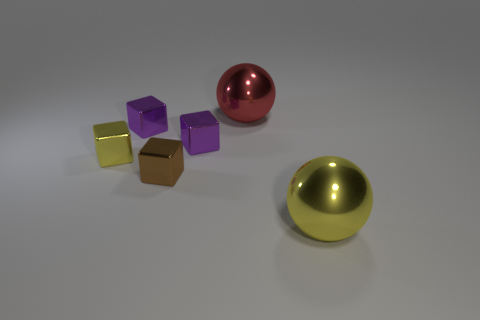Subtract all purple blocks. How many were subtracted if there are1purple blocks left? 1 Add 3 yellow shiny things. How many objects exist? 9 Subtract all yellow metal cubes. How many cubes are left? 3 Subtract 1 cubes. How many cubes are left? 3 Subtract all green cubes. Subtract all purple spheres. How many cubes are left? 4 Subtract all blue balls. How many green cubes are left? 0 Subtract all purple metal cubes. Subtract all purple metallic things. How many objects are left? 2 Add 3 large balls. How many large balls are left? 5 Add 2 red objects. How many red objects exist? 3 Subtract all brown cubes. How many cubes are left? 3 